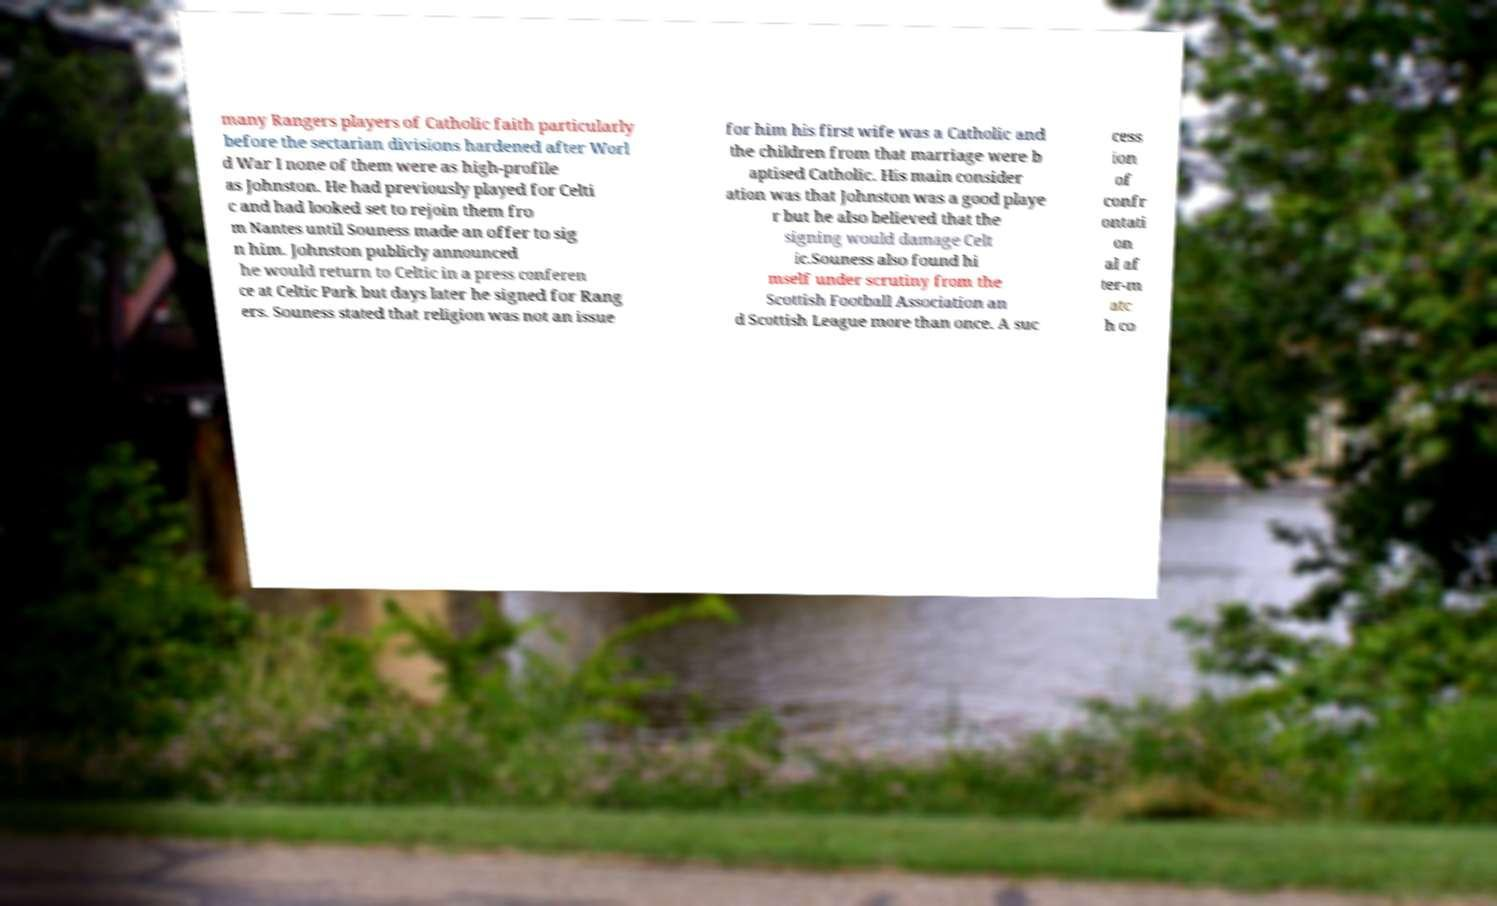Can you accurately transcribe the text from the provided image for me? many Rangers players of Catholic faith particularly before the sectarian divisions hardened after Worl d War I none of them were as high-profile as Johnston. He had previously played for Celti c and had looked set to rejoin them fro m Nantes until Souness made an offer to sig n him. Johnston publicly announced he would return to Celtic in a press conferen ce at Celtic Park but days later he signed for Rang ers. Souness stated that religion was not an issue for him his first wife was a Catholic and the children from that marriage were b aptised Catholic. His main consider ation was that Johnston was a good playe r but he also believed that the signing would damage Celt ic.Souness also found hi mself under scrutiny from the Scottish Football Association an d Scottish League more than once. A suc cess ion of confr ontati on al af ter-m atc h co 